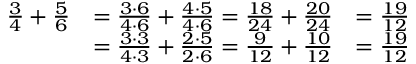<formula> <loc_0><loc_0><loc_500><loc_500>{ \begin{array} { r l r } { { \frac { 3 } { 4 } } + { \frac { 5 } { 6 } } } & { = { \frac { 3 \cdot 6 } { 4 \cdot 6 } } + { \frac { 4 \cdot 5 } { 4 \cdot 6 } } = { \frac { 1 8 } { 2 4 } } + { \frac { 2 0 } { 2 4 } } } & { = { \frac { 1 9 } { 1 2 } } } \\ & { = { \frac { 3 \cdot 3 } { 4 \cdot 3 } } + { \frac { 2 \cdot 5 } { 2 \cdot 6 } } = { \frac { 9 } { 1 2 } } + { \frac { 1 0 } { 1 2 } } } & { = { \frac { 1 9 } { 1 2 } } } \end{array} }</formula> 